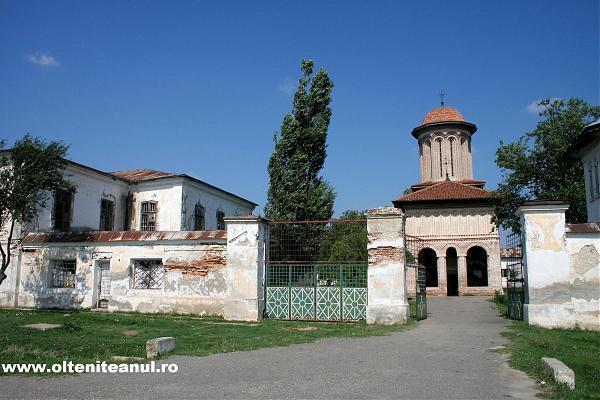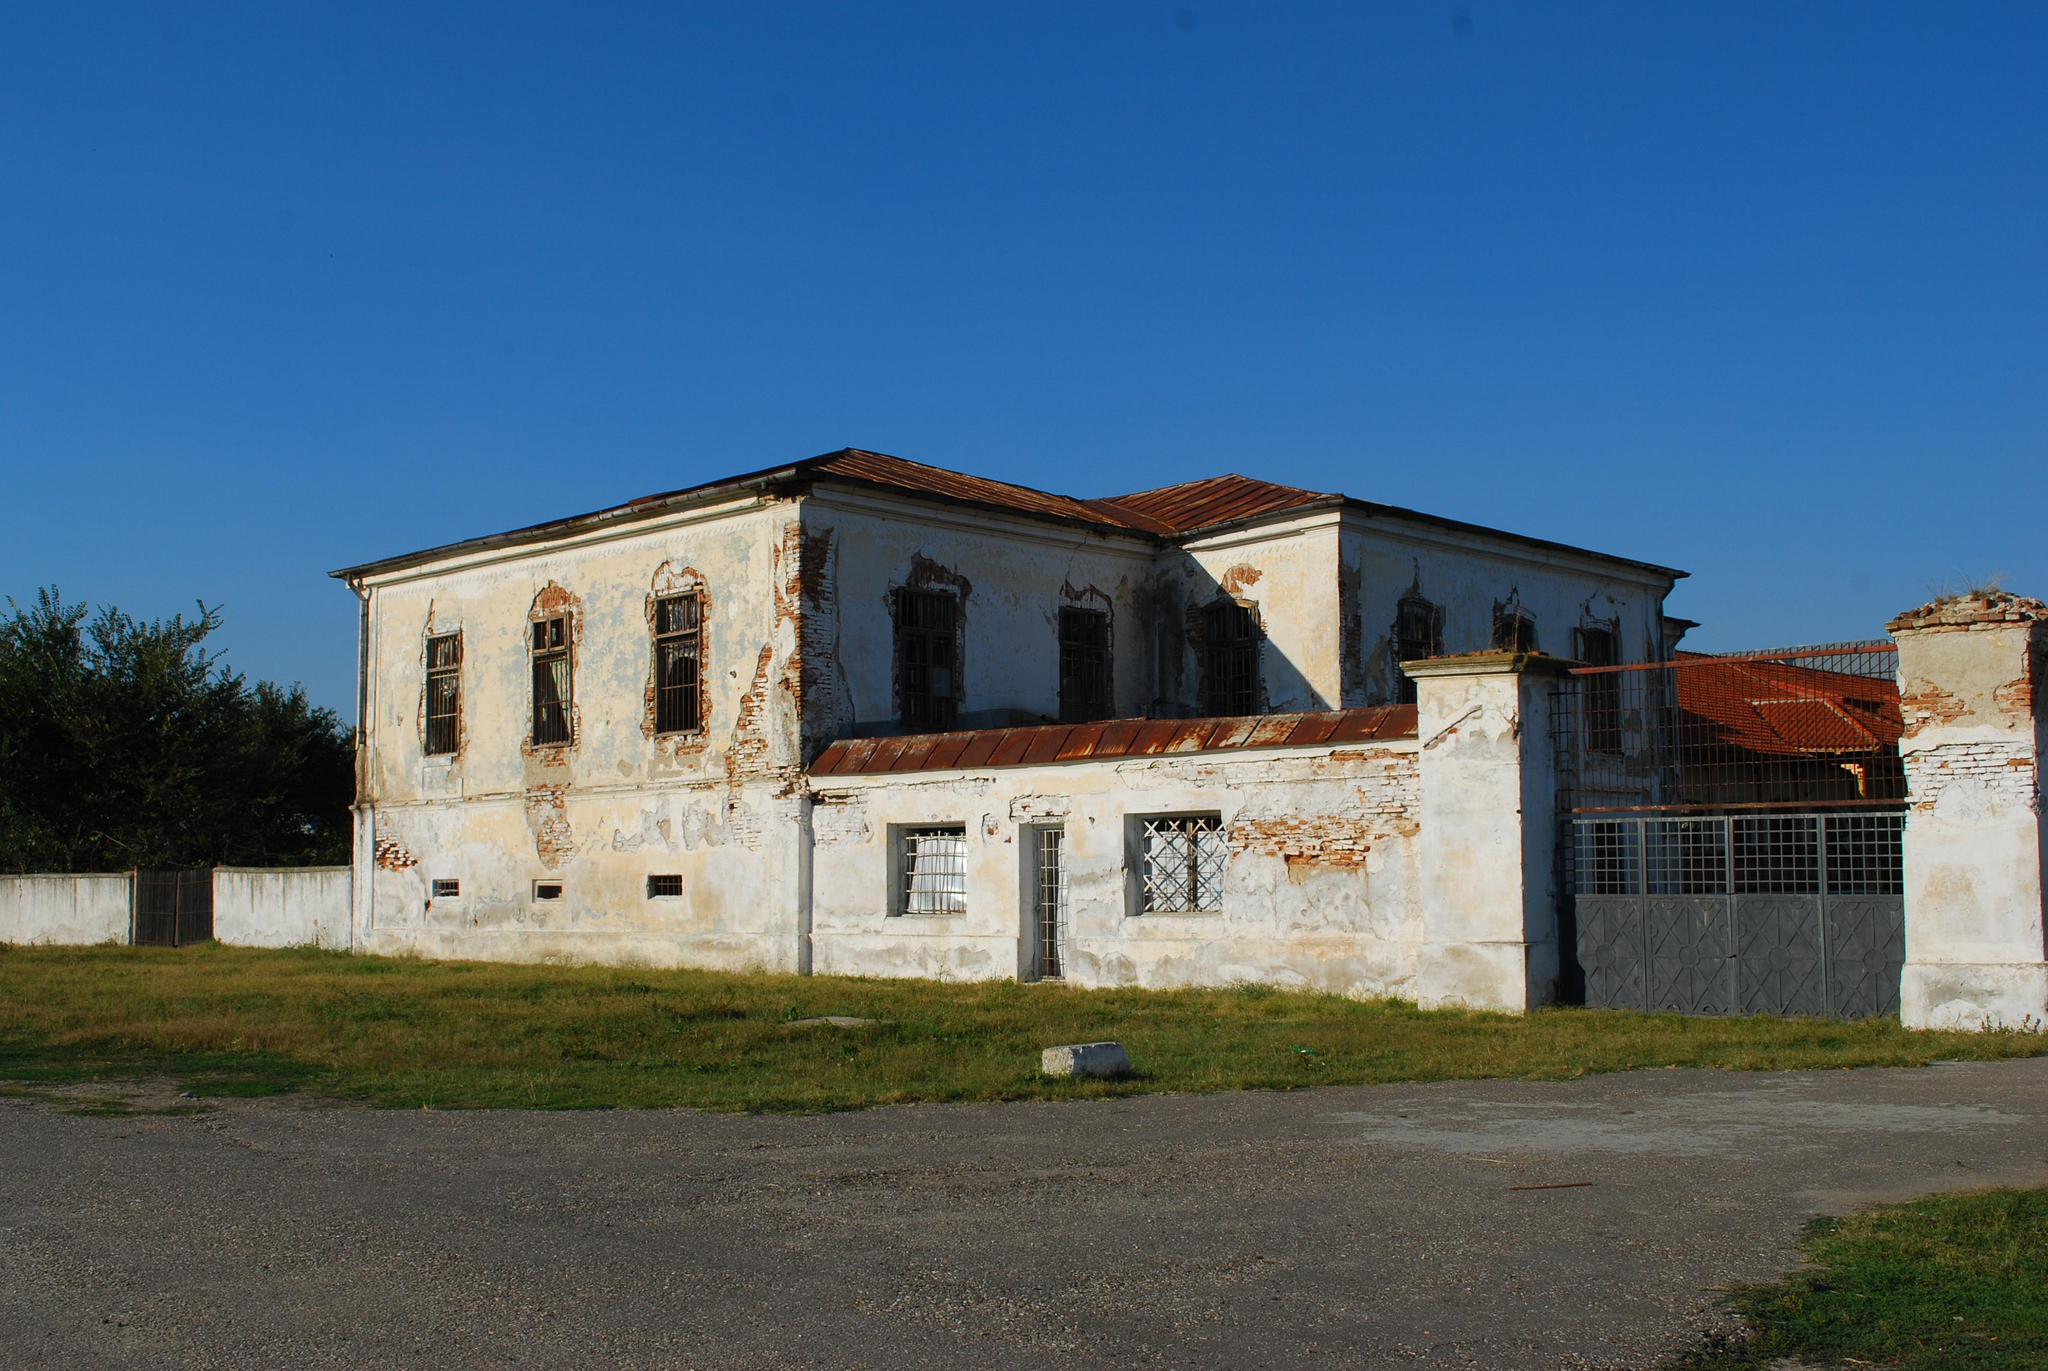The first image is the image on the left, the second image is the image on the right. Given the left and right images, does the statement "There is at least one terrace in one of the images." hold true? Answer yes or no. No. 